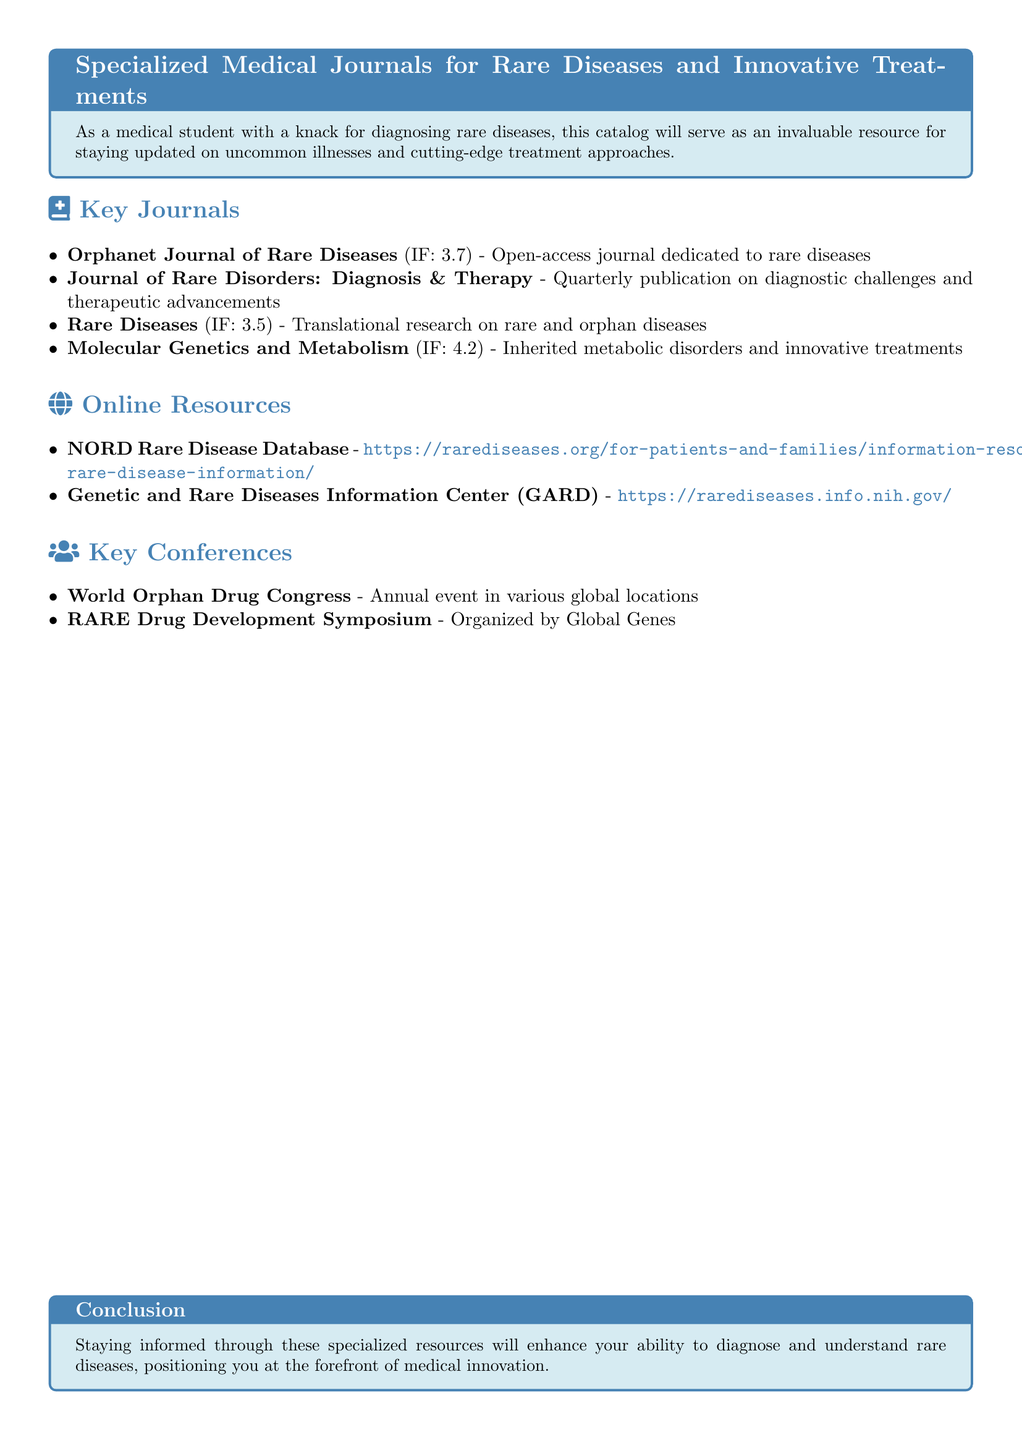What is the impact factor of the Orphanet Journal of Rare Diseases? The impact factor is a numerical measure that reflects the yearly average number of citations to articles published in the journal, which for the Orphanet Journal of Rare Diseases is 3.7.
Answer: 3.7 How often is the Journal of Rare Disorders: Diagnosis & Therapy published? The publication frequency is specified in the document, indicating the journal is released quarterly.
Answer: Quarterly What is the focus of the Rare Diseases journal? The focus of this journal is elaborated in the document, pointing to translational research dedicated to rare and orphan diseases.
Answer: Translational research on rare and orphan diseases Which online resource is associated with the Genetic and Rare Diseases Information Center? The document specifies the URL for more information linked to the Genetic and Rare Diseases Information Center as part of its description, thereby identifying it as a relevant online resource.
Answer: https://rarediseases.info.nih.gov/ What is the annual event mentioned that focuses on orphan drugs? The document mentions an annual event by name, indicating this is a notable conference for professionals in the field of orphan drugs.
Answer: World Orphan Drug Congress How many journals are listed under Key Journals? The count of journals is based on the bulleted list provided in the document, detailing the journals focusing on rare diseases.
Answer: 4 What is the color of the tcolorbox in the document? The document specifies the color scheme used for the tcolorbox, indicating it involves a light blue background.
Answer: Light blue 